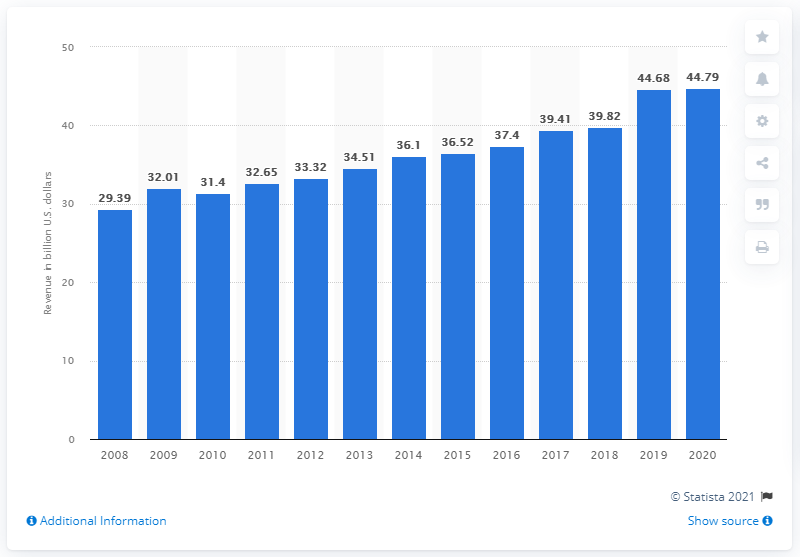Indicate a few pertinent items in this graphic. Allstate's revenue in 2008 was 29.39 billion dollars. Allstate generated $44.79 million in revenue in 2020. 